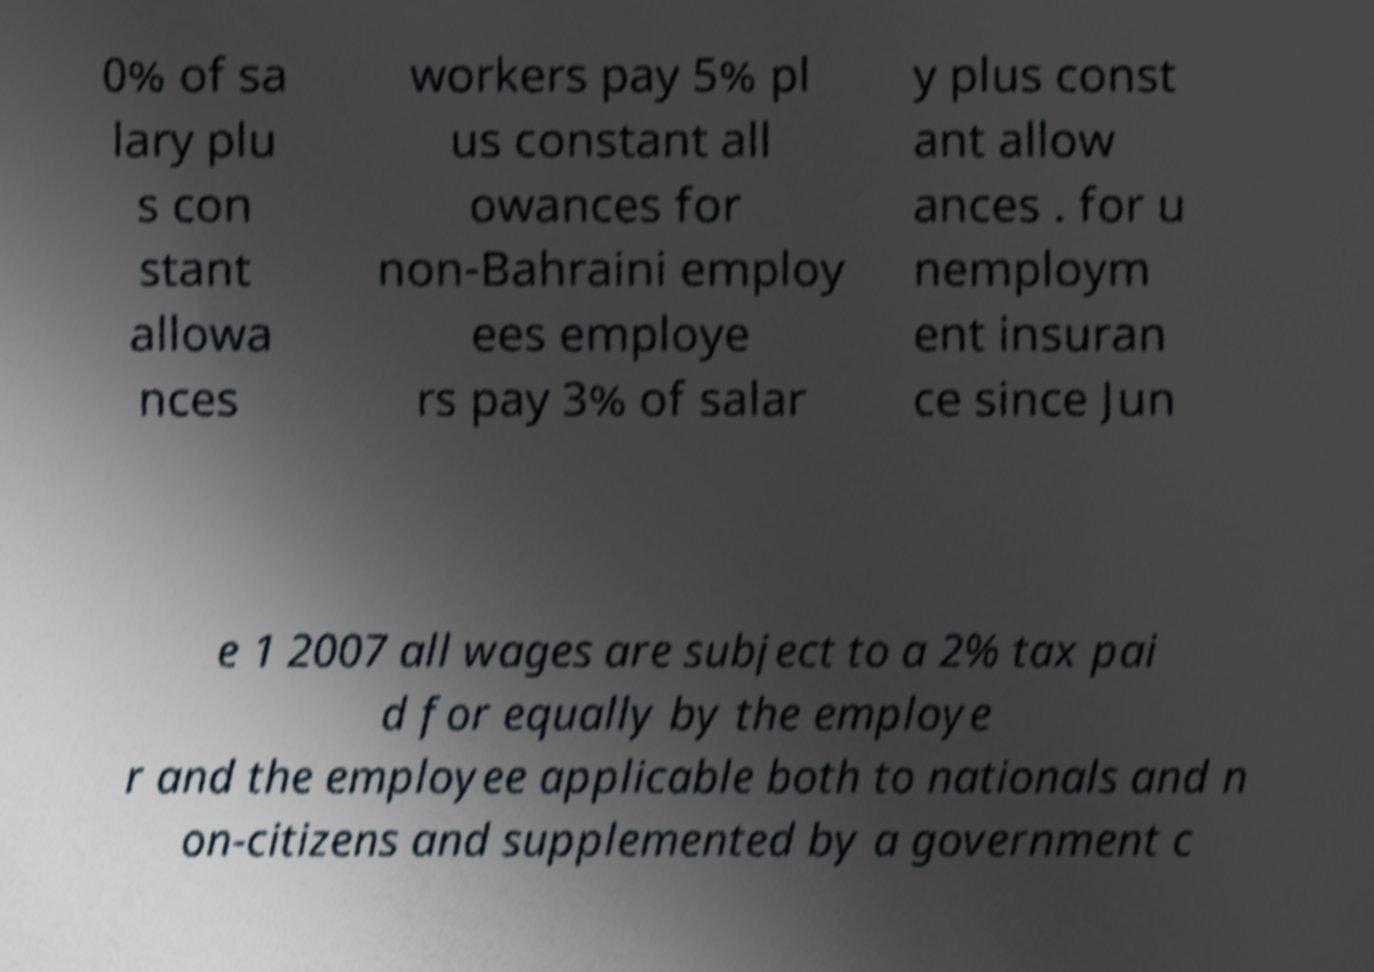For documentation purposes, I need the text within this image transcribed. Could you provide that? 0% of sa lary plu s con stant allowa nces workers pay 5% pl us constant all owances for non-Bahraini employ ees employe rs pay 3% of salar y plus const ant allow ances . for u nemploym ent insuran ce since Jun e 1 2007 all wages are subject to a 2% tax pai d for equally by the employe r and the employee applicable both to nationals and n on-citizens and supplemented by a government c 